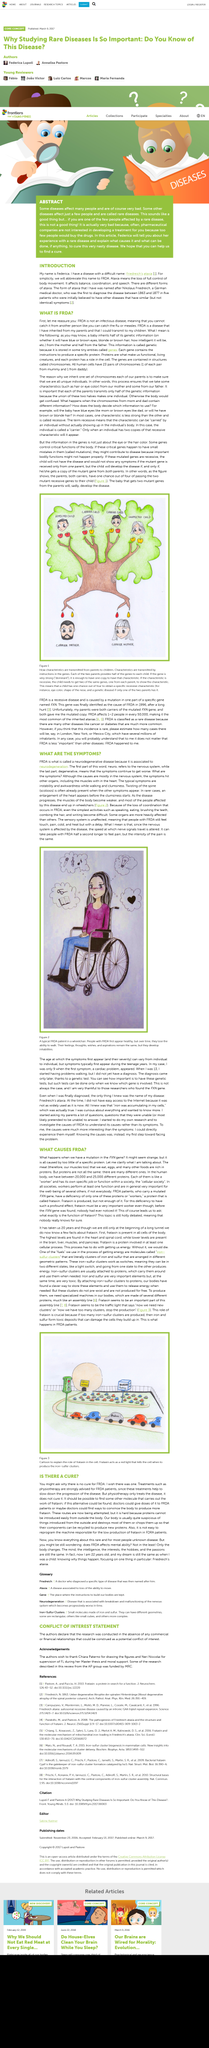Outline some significant characteristics in this image. Federica will inform you about her experience with a rare disease. Ataxia refers to the loss of full control of body movement, leading to difficulties with coordination and balance. The abstract states that some diseases affect many people. The title of the red book is "Diseases and Disorders". Friedreich's ataxia is a genetic disorder that is abbreviated as FRDA. 